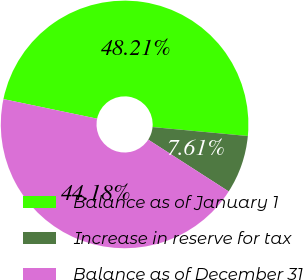<chart> <loc_0><loc_0><loc_500><loc_500><pie_chart><fcel>Balance as of January 1<fcel>Increase in reserve for tax<fcel>Balance as of December 31<nl><fcel>48.21%<fcel>7.61%<fcel>44.18%<nl></chart> 